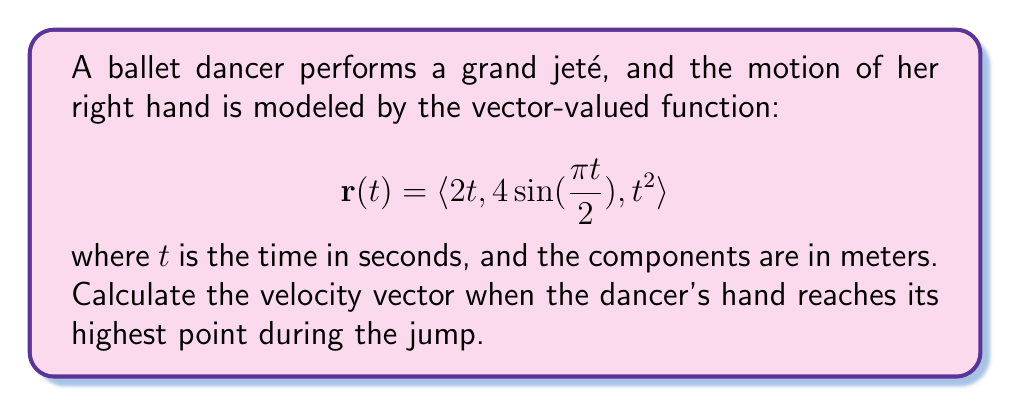Teach me how to tackle this problem. To solve this problem, we need to follow these steps:

1) First, we need to find when the dancer's hand reaches its highest point. This occurs when the y-component (vertical component) of the position vector is at its maximum.

2) The y-component of the position vector is $4\sin(\frac{\pi t}{2})$. This function reaches its maximum when $\sin(\frac{\pi t}{2}) = 1$, which occurs when $\frac{\pi t}{2} = \frac{\pi}{2}$, or when $t = 1$ second.

3) Now that we know the time at which the hand is at its highest point, we need to calculate the velocity vector at this time. The velocity vector is the derivative of the position vector with respect to time:

   $$\mathbf{v}(t) = \frac{d}{dt}\mathbf{r}(t) = \langle \frac{d}{dt}(2t), \frac{d}{dt}(4\sin(\frac{\pi t}{2})), \frac{d}{dt}(t^2) \rangle$$

4) Let's calculate each component:
   
   - $\frac{d}{dt}(2t) = 2$
   - $\frac{d}{dt}(4\sin(\frac{\pi t}{2})) = 4 \cdot \frac{\pi}{2} \cos(\frac{\pi t}{2}) = 2\pi \cos(\frac{\pi t}{2})$
   - $\frac{d}{dt}(t^2) = 2t$

5) Therefore, the velocity vector is:

   $$\mathbf{v}(t) = \langle 2, 2\pi \cos(\frac{\pi t}{2}), 2t \rangle$$

6) Now we substitute $t = 1$ into this velocity vector:

   $$\mathbf{v}(1) = \langle 2, 2\pi \cos(\frac{\pi}{2}), 2(1) \rangle = \langle 2, 0, 2 \rangle$$

   Note that $\cos(\frac{\pi}{2}) = 0$

Therefore, the velocity vector when the dancer's hand is at its highest point is $\langle 2, 0, 2 \rangle$ meters per second.
Answer: $\langle 2, 0, 2 \rangle$ m/s 